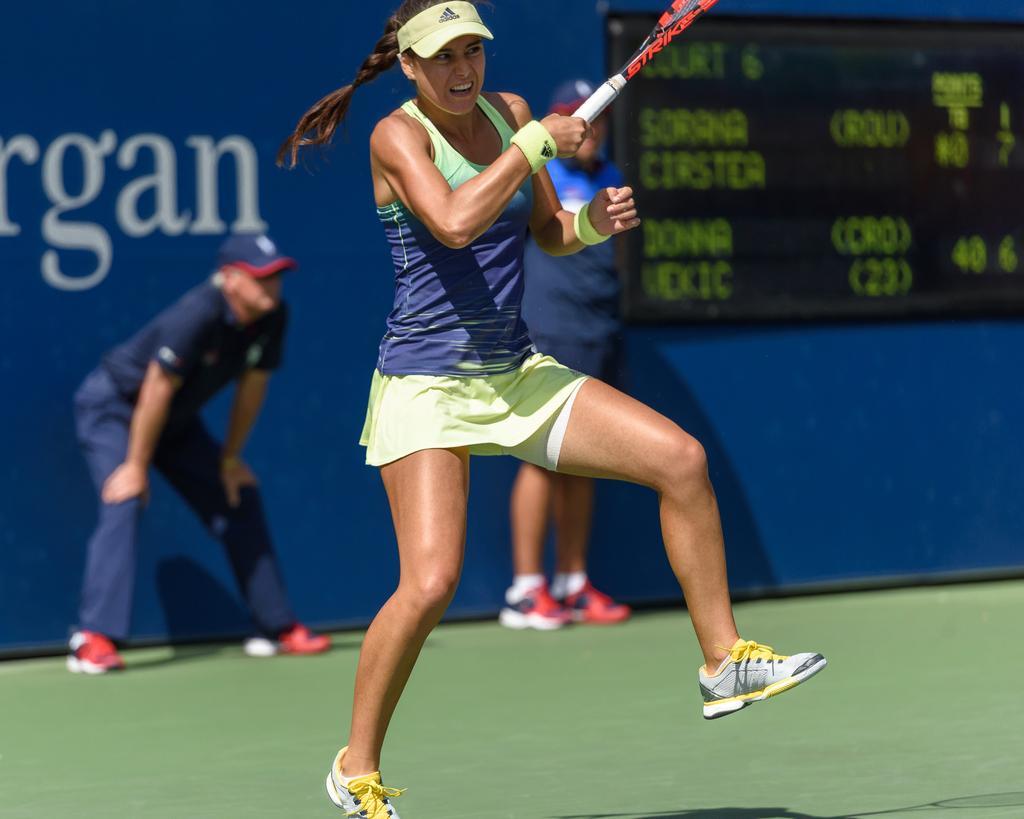Describe this image in one or two sentences. This is the picture taken in the outdoors. The woman in blue and green t shirt was holding a tennis racket and jumping. Behind the woman there are two other persons are standing on the floor. Background of the people is a banner and a score board. 